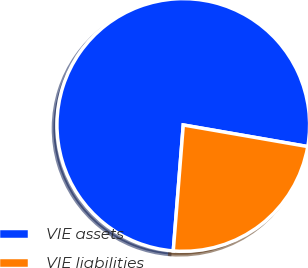Convert chart to OTSL. <chart><loc_0><loc_0><loc_500><loc_500><pie_chart><fcel>VIE assets<fcel>VIE liabilities<nl><fcel>76.47%<fcel>23.53%<nl></chart> 